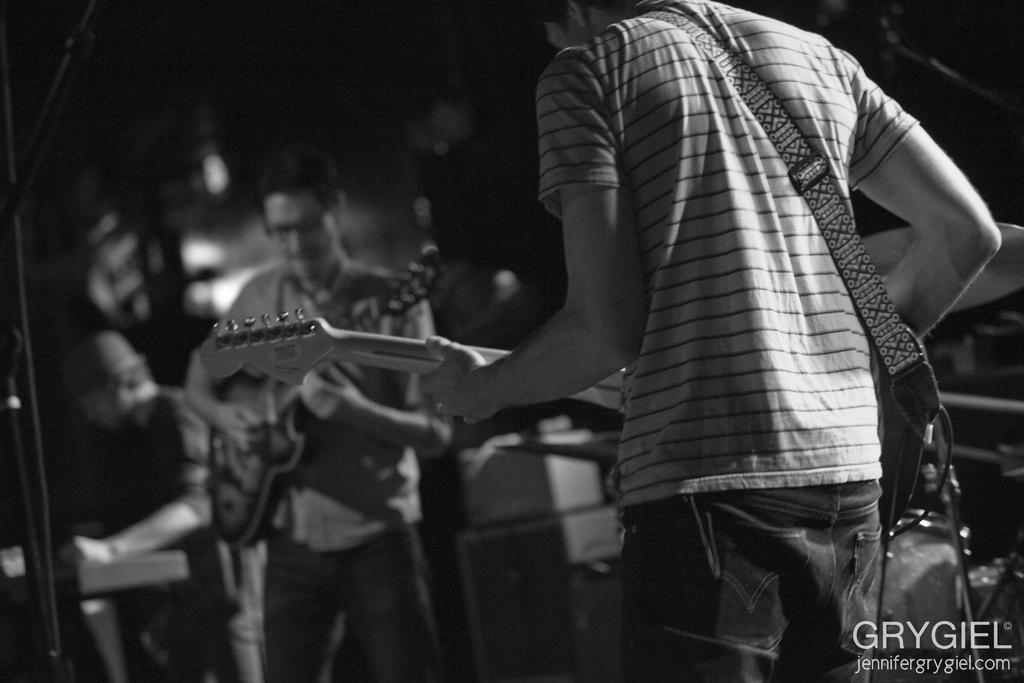What is happening in the image? There is a group of musicians in the image, and they are playing musical instruments. Can you describe the musical instruments being played? The musicians are playing musical instruments, but the specific instruments cannot be identified from the provided facts. What else can be seen in the image related to music? There are musical instruments in the background of the image. What type of curtain is hanging behind the musicians in the image? There is no curtain visible in the image. How much income do the musicians earn from playing their instruments in the image? The image does not provide information about the musicians' income. 